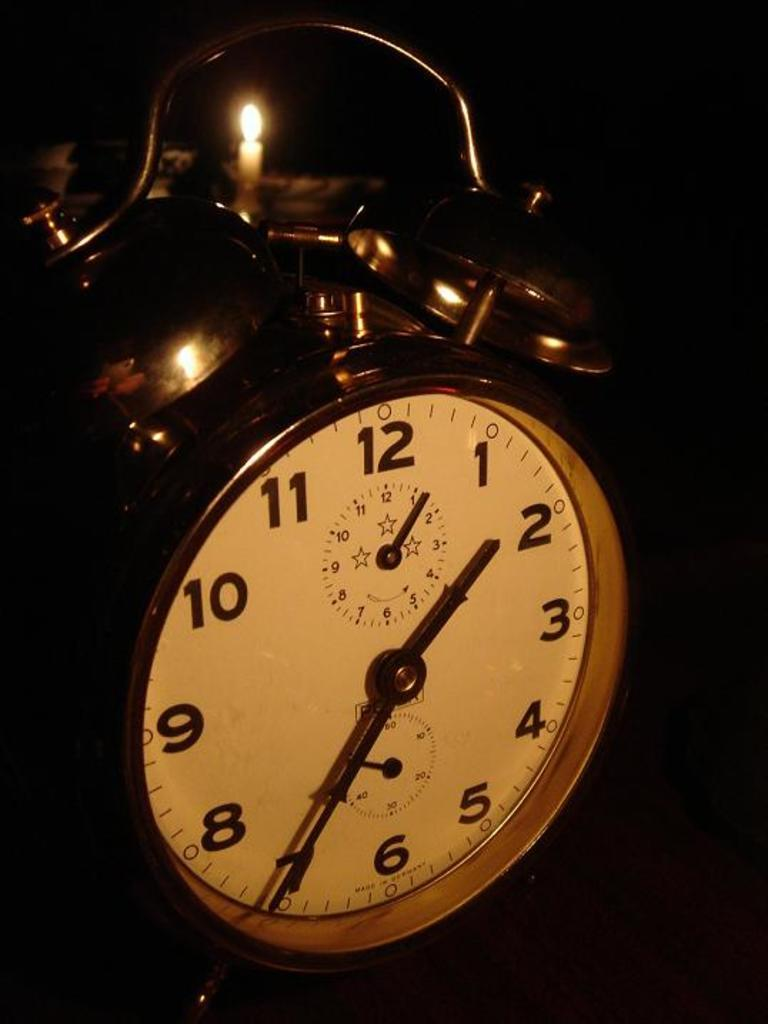<image>
Share a concise interpretation of the image provided. A metal alarm clock has the time as 1:35. 